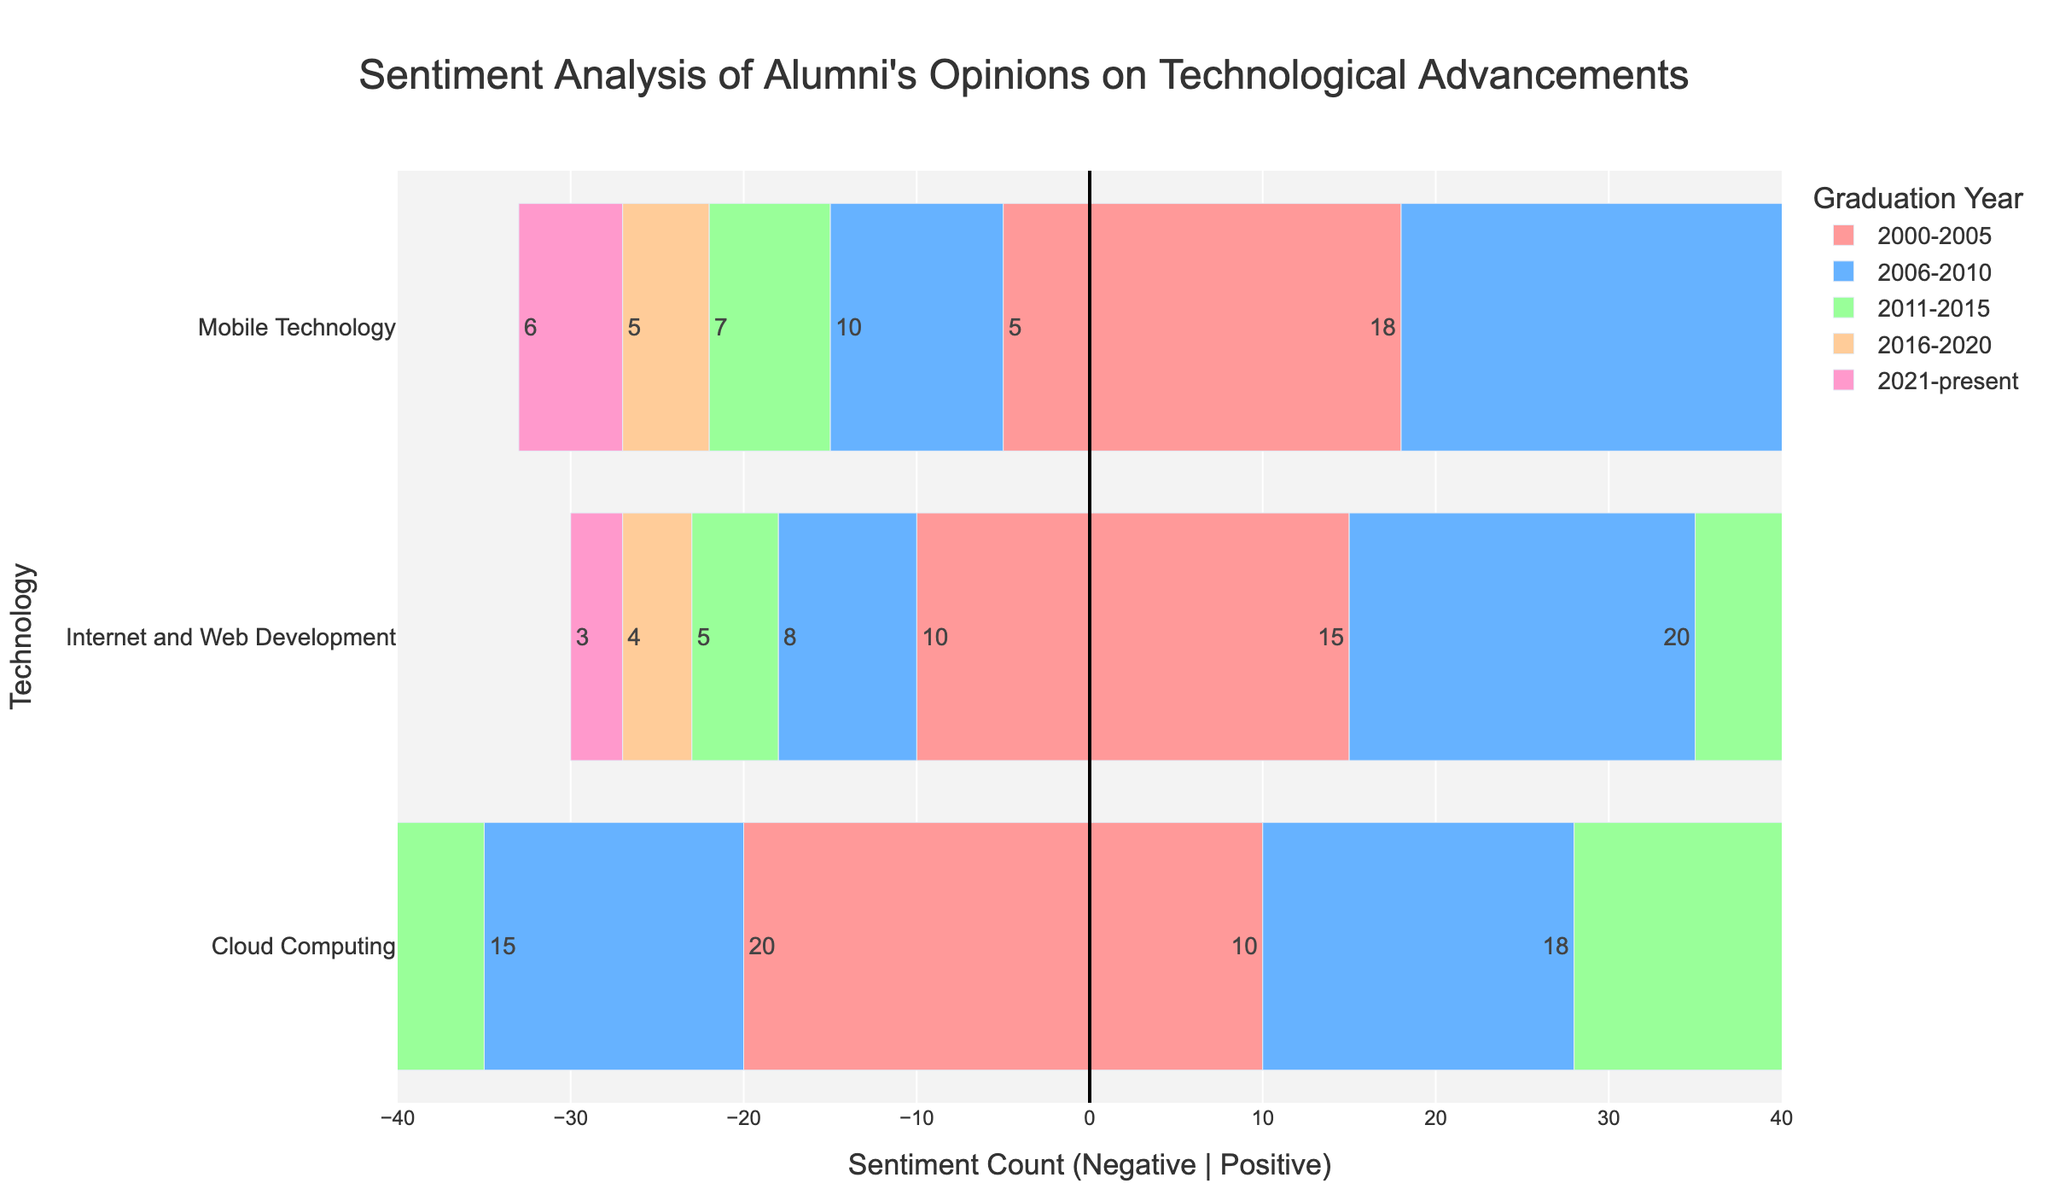When did alumni show the highest positive sentiment for Mobile Technology? Based on the visual information, the bar representing positive sentiment for Mobile Technology (the blue segments) is the longest for the 2016-2020 period. No other segment surpasses this length.
Answer: 2016-2020 Compare the sentiments for Cloud Computing between 2000-2005 and 2016-2020. In the 2000-2005 period, Cloud Computing has a positive sentiment bar of 10 and a negative sentiment bar of -20. For 2016-2020, the positive sentiment bar is 35, and the negative sentiment bar is -8. Hence, 2016-2020 has higher positive and much lower negative sentiments compared to 2000-2005.
Answer: 2016-2020 has higher positive and lower negative sentiments Which technology had the highest negative sentiment in the 2000-2005 period? By observing the length of the negative sentiment bars (red segments) for 2000-2005, Cloud Computing has the longest negative bar with -20.
Answer: Cloud Computing Considering the 2006-2010 period, which sentiment-total sums to a net positive value for Cloud Computing? For 2006-2010, Cloud Computing shows a positive sentiment count of 18 and a negative sentiment count of -15. Adding them together (18 + (-15)) results in a net positive value of 3.
Answer: Net positive of 3 What is the most prominently positive sentiment among Internet and Web Development across all periods? The visual analysis shows that for Internet and Web Development, the positive sentiment (the blue bar segments) reaches its peak during 2016-2020 with a value of 24.
Answer: 2016-2020 Compare the levels of negative sentiment for Mobile Technology in the timeframes 2000-2005 and 2021-present. In the 2000-2005 period, the negative sentiment for Mobile Technology is -5. In the 2021-present period, the negative sentiment is -6. The values visually indicate that the 2021-present period shows slightly higher negative sentiment by 1 unit.
Answer: 2021-present has higher negative sentiment by 1 unit What is the average positive sentiment for Cloud Computing from 2011 to the present? The positive sentiment for Cloud Computing in 2011-2015 is 30, for 2016-2020 is 35, and for 2021-present is 34. The average can be calculated as (30 + 35 + 34) / 3 = 99 / 3 = 33.
Answer: 33 How does the positive sentiment for Mobile Technology in 2000-2005 compare to the same technology in 2006-2010? The positive sentiment for Mobile Technology in 2000-2005 is 18, while in 2006-2010, it is 25. Comparing the two, 2006-2010 has 7 more positive sentiments than 2000-2005.
Answer: 2006-2010 has 7 more positive sentiments Which period observed the lowest positive sentiment for Internet and Web Development? By looking at the blue bars corresponding to the positive sentiment for Internet and Web Development, the shortest one is in the 2000-2005 period, with a value of 15.
Answer: 2000-2005 